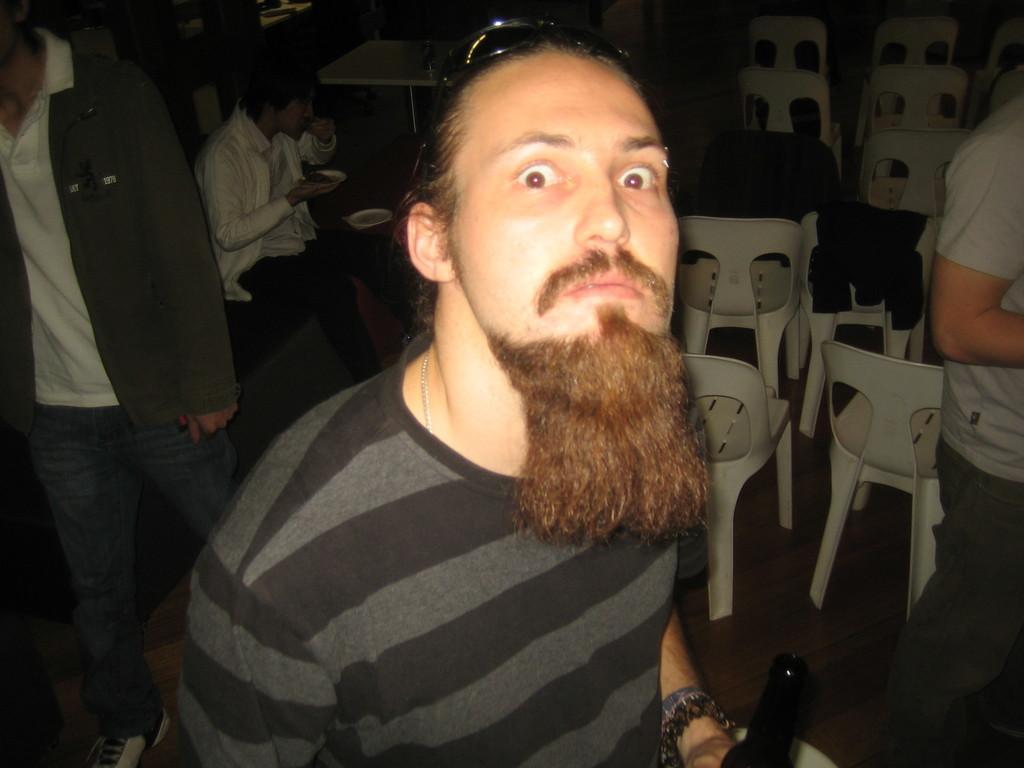Could you give a brief overview of what you see in this image? In this picture I can see a man is standing. The man is wearing a t shirt. In the background, I can see people among them a person is sitting. On the right side, I can see white color chairs. 